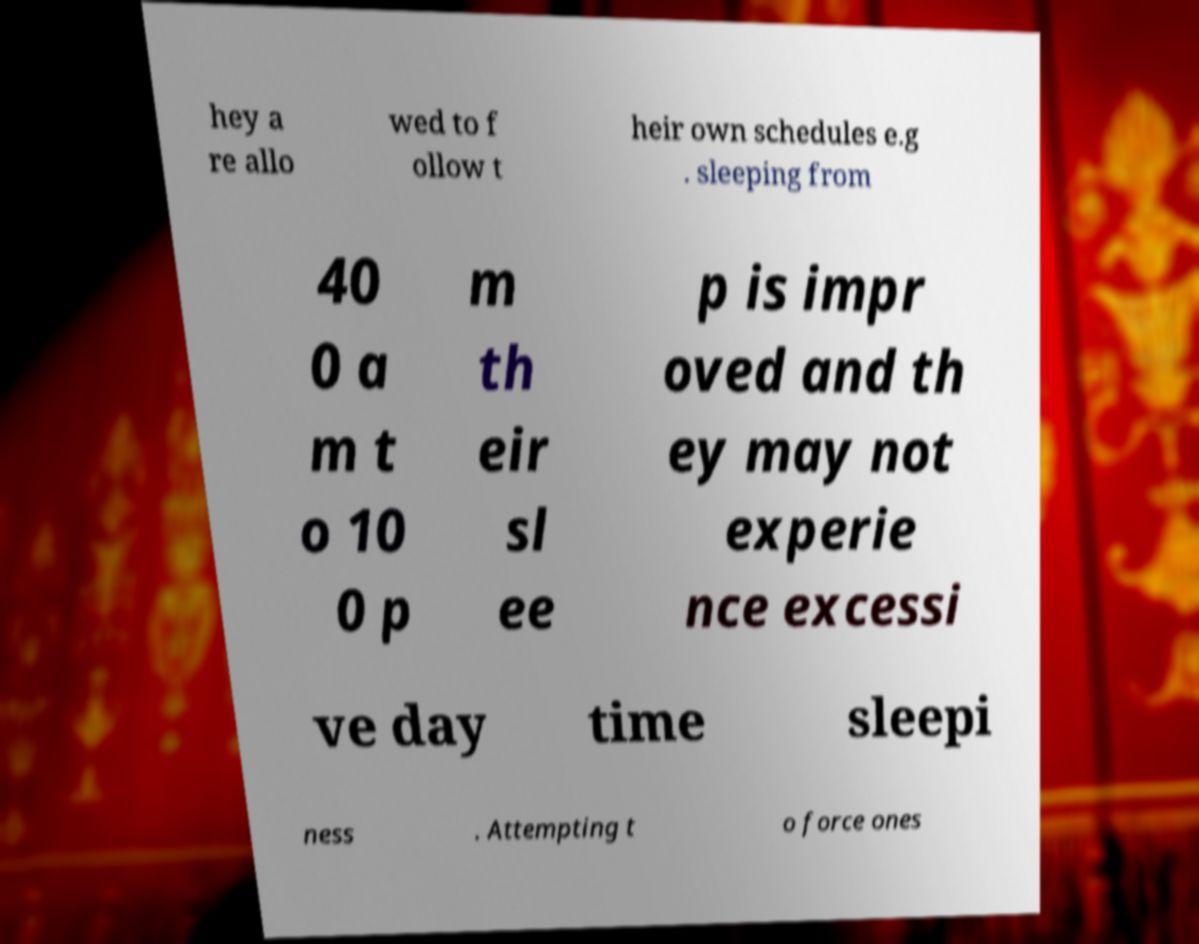Could you assist in decoding the text presented in this image and type it out clearly? hey a re allo wed to f ollow t heir own schedules e.g . sleeping from 40 0 a m t o 10 0 p m th eir sl ee p is impr oved and th ey may not experie nce excessi ve day time sleepi ness . Attempting t o force ones 